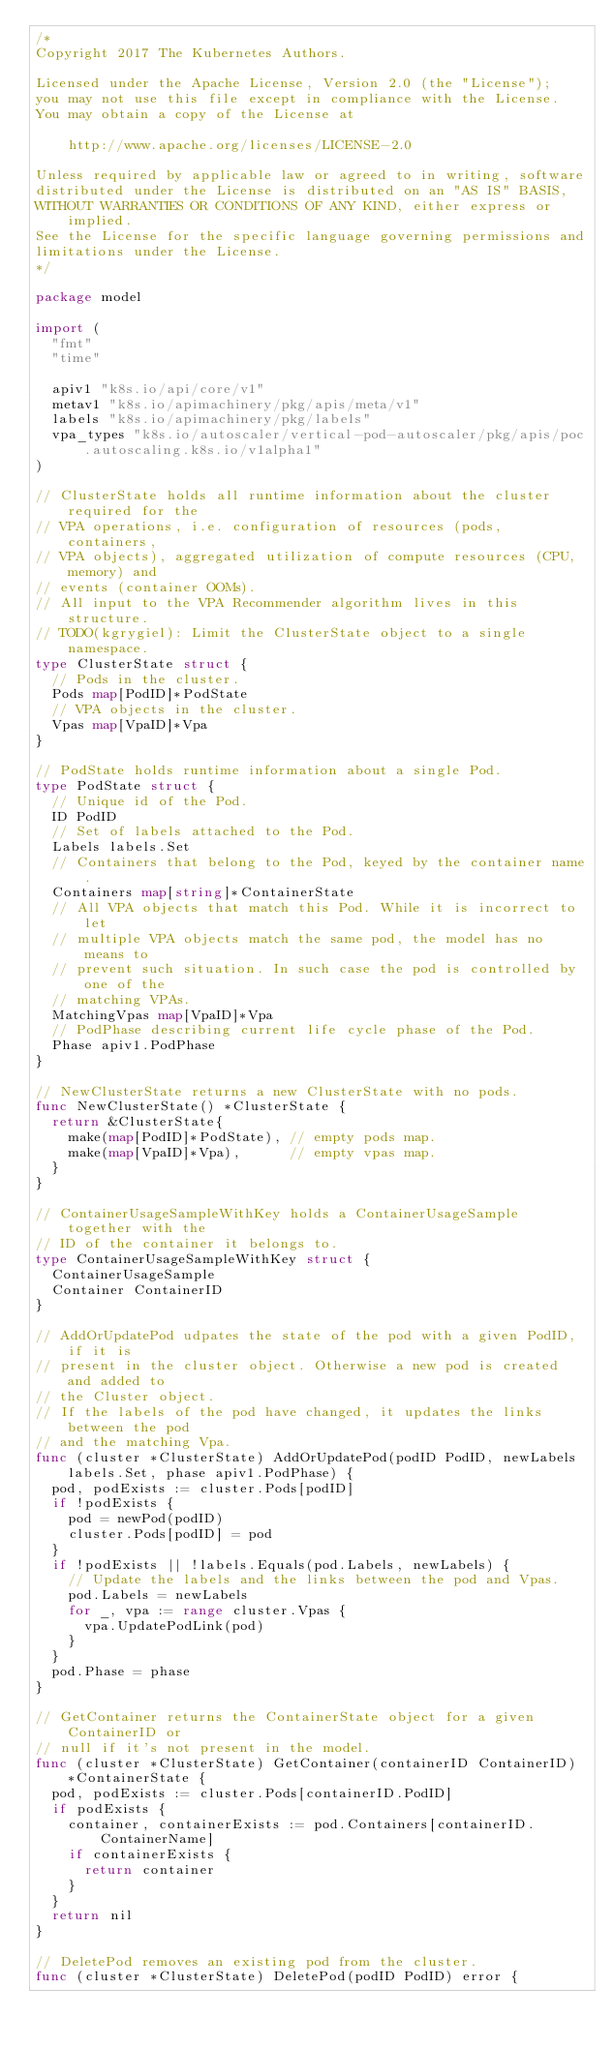<code> <loc_0><loc_0><loc_500><loc_500><_Go_>/*
Copyright 2017 The Kubernetes Authors.

Licensed under the Apache License, Version 2.0 (the "License");
you may not use this file except in compliance with the License.
You may obtain a copy of the License at

    http://www.apache.org/licenses/LICENSE-2.0

Unless required by applicable law or agreed to in writing, software
distributed under the License is distributed on an "AS IS" BASIS,
WITHOUT WARRANTIES OR CONDITIONS OF ANY KIND, either express or implied.
See the License for the specific language governing permissions and
limitations under the License.
*/

package model

import (
	"fmt"
	"time"

	apiv1 "k8s.io/api/core/v1"
	metav1 "k8s.io/apimachinery/pkg/apis/meta/v1"
	labels "k8s.io/apimachinery/pkg/labels"
	vpa_types "k8s.io/autoscaler/vertical-pod-autoscaler/pkg/apis/poc.autoscaling.k8s.io/v1alpha1"
)

// ClusterState holds all runtime information about the cluster required for the
// VPA operations, i.e. configuration of resources (pods, containers,
// VPA objects), aggregated utilization of compute resources (CPU, memory) and
// events (container OOMs).
// All input to the VPA Recommender algorithm lives in this structure.
// TODO(kgrygiel): Limit the ClusterState object to a single namespace.
type ClusterState struct {
	// Pods in the cluster.
	Pods map[PodID]*PodState
	// VPA objects in the cluster.
	Vpas map[VpaID]*Vpa
}

// PodState holds runtime information about a single Pod.
type PodState struct {
	// Unique id of the Pod.
	ID PodID
	// Set of labels attached to the Pod.
	Labels labels.Set
	// Containers that belong to the Pod, keyed by the container name.
	Containers map[string]*ContainerState
	// All VPA objects that match this Pod. While it is incorrect to let
	// multiple VPA objects match the same pod, the model has no means to
	// prevent such situation. In such case the pod is controlled by one of the
	// matching VPAs.
	MatchingVpas map[VpaID]*Vpa
	// PodPhase describing current life cycle phase of the Pod.
	Phase apiv1.PodPhase
}

// NewClusterState returns a new ClusterState with no pods.
func NewClusterState() *ClusterState {
	return &ClusterState{
		make(map[PodID]*PodState), // empty pods map.
		make(map[VpaID]*Vpa),      // empty vpas map.
	}
}

// ContainerUsageSampleWithKey holds a ContainerUsageSample together with the
// ID of the container it belongs to.
type ContainerUsageSampleWithKey struct {
	ContainerUsageSample
	Container ContainerID
}

// AddOrUpdatePod udpates the state of the pod with a given PodID, if it is
// present in the cluster object. Otherwise a new pod is created and added to
// the Cluster object.
// If the labels of the pod have changed, it updates the links between the pod
// and the matching Vpa.
func (cluster *ClusterState) AddOrUpdatePod(podID PodID, newLabels labels.Set, phase apiv1.PodPhase) {
	pod, podExists := cluster.Pods[podID]
	if !podExists {
		pod = newPod(podID)
		cluster.Pods[podID] = pod
	}
	if !podExists || !labels.Equals(pod.Labels, newLabels) {
		// Update the labels and the links between the pod and Vpas.
		pod.Labels = newLabels
		for _, vpa := range cluster.Vpas {
			vpa.UpdatePodLink(pod)
		}
	}
	pod.Phase = phase
}

// GetContainer returns the ContainerState object for a given ContainerID or
// null if it's not present in the model.
func (cluster *ClusterState) GetContainer(containerID ContainerID) *ContainerState {
	pod, podExists := cluster.Pods[containerID.PodID]
	if podExists {
		container, containerExists := pod.Containers[containerID.ContainerName]
		if containerExists {
			return container
		}
	}
	return nil
}

// DeletePod removes an existing pod from the cluster.
func (cluster *ClusterState) DeletePod(podID PodID) error {</code> 